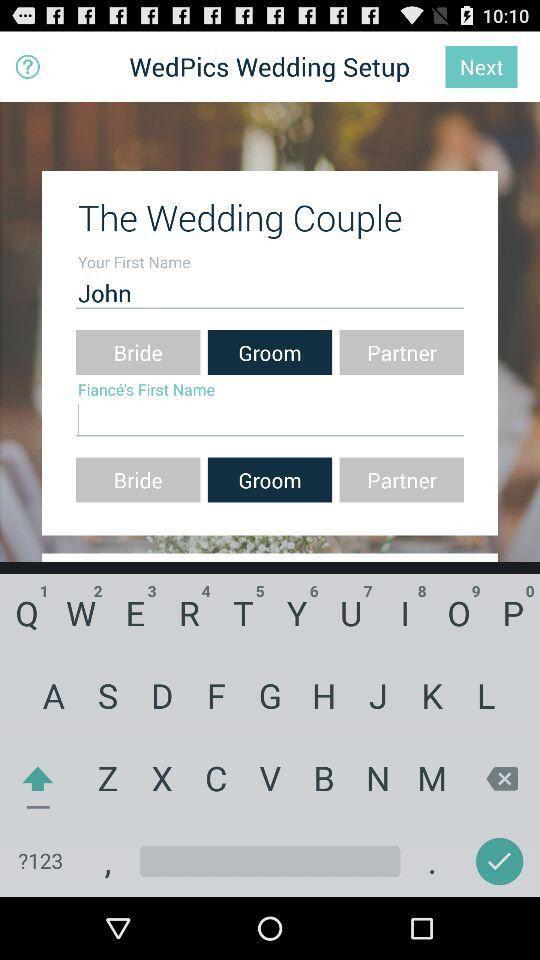What application is asking for permission? The application asking for permission is "WedPics". 